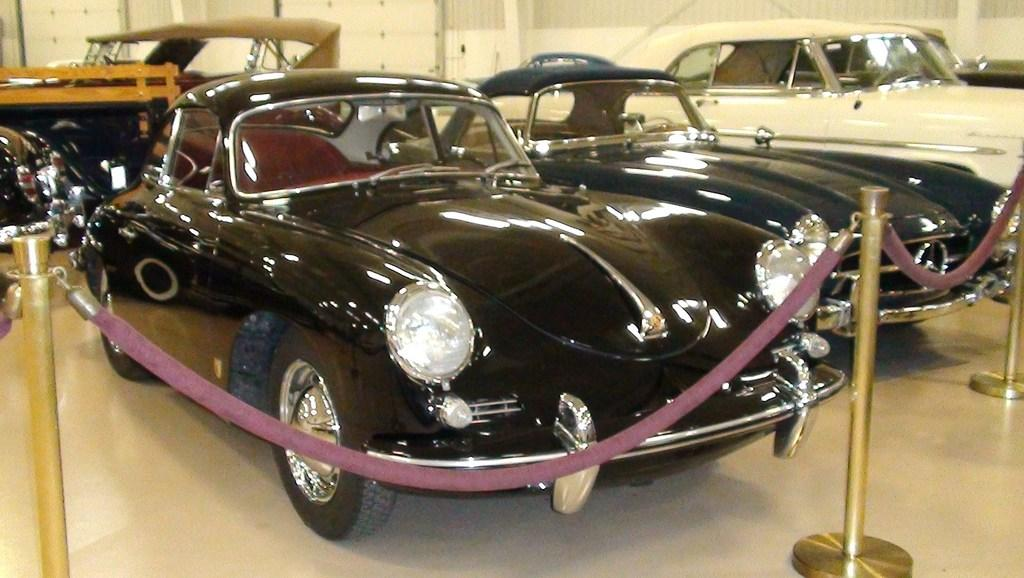What type of vehicles can be seen in the image? There are cars in the image. What materials are used for the rods in the image? The rods in the image are made of metal. What type of flexible material is present in the image? There are ropes in the image. How many pizzas are being delivered by the cars in the image? There is no information about pizzas or deliveries in the image; it only shows cars, metal rods, and ropes. Can you describe the ocean view from the image? There is no ocean or water body present in the image. 